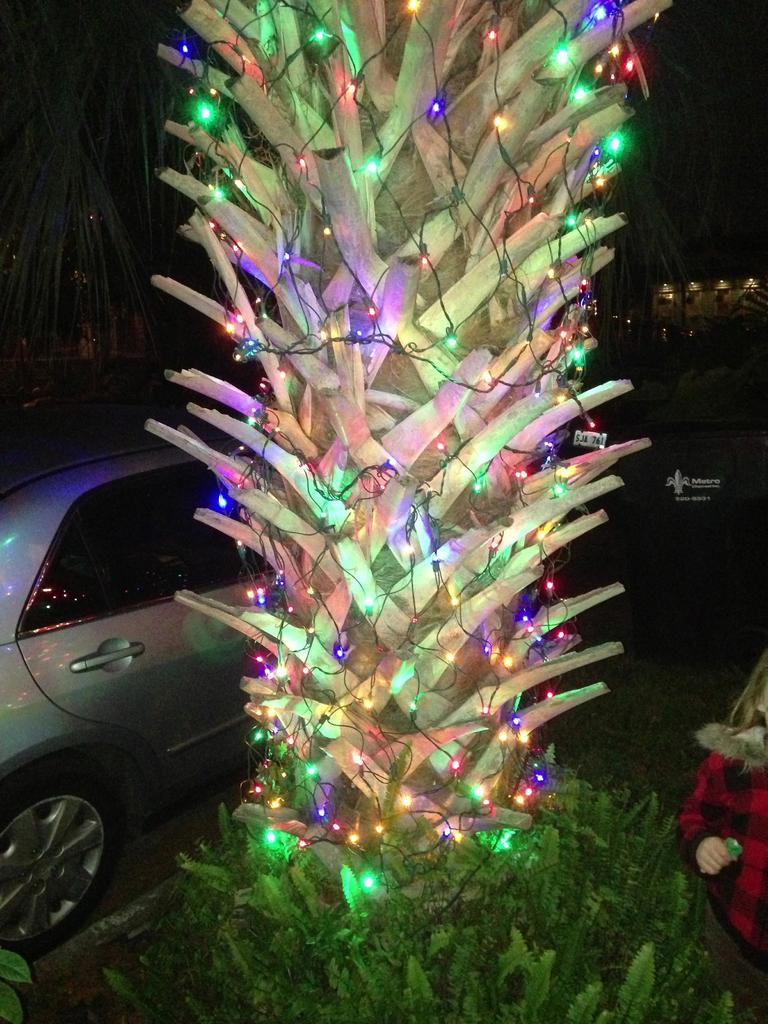How would you summarize this image in a sentence or two? In this image I can see a tree decorated with colorful lights. Back I can see a vehicle,person and background is dark in color. 